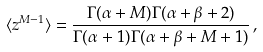Convert formula to latex. <formula><loc_0><loc_0><loc_500><loc_500>\langle z ^ { M - 1 } \rangle = \frac { \Gamma ( \alpha + M ) \Gamma ( \alpha + \beta + 2 ) } { \Gamma ( \alpha + 1 ) \Gamma ( \alpha + \beta + M + 1 ) } \, ,</formula> 